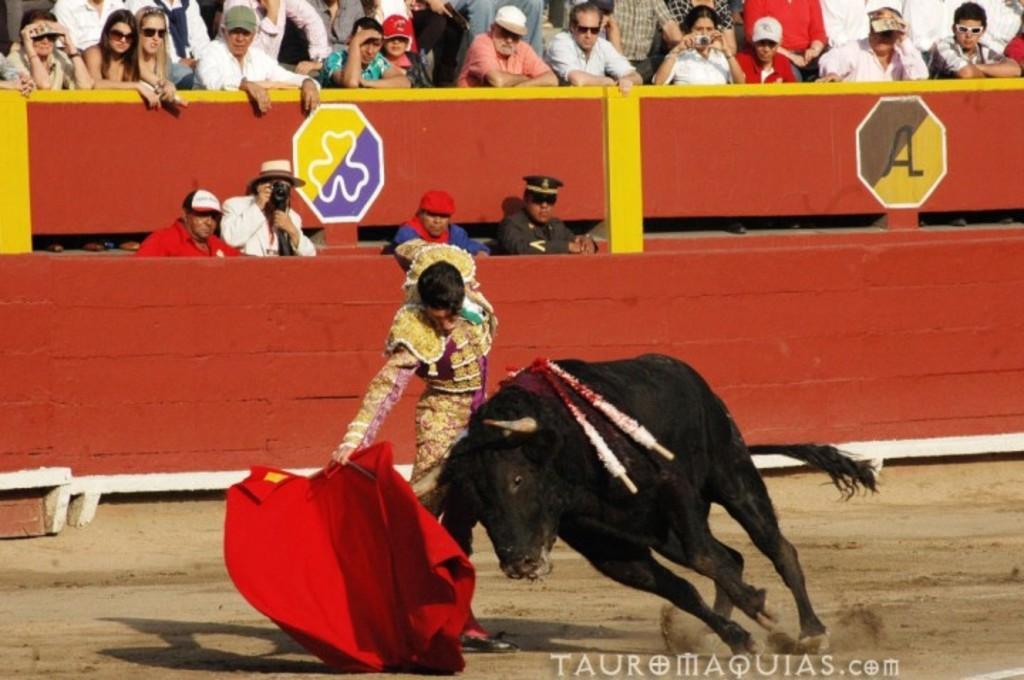Can you describe this image briefly? In the image we can see there is a man standing and he is holding red colour cloth. Beside him there is a bull standing on the ground and the ground is covered with sand. Behind there are spectators standing and watching them. 